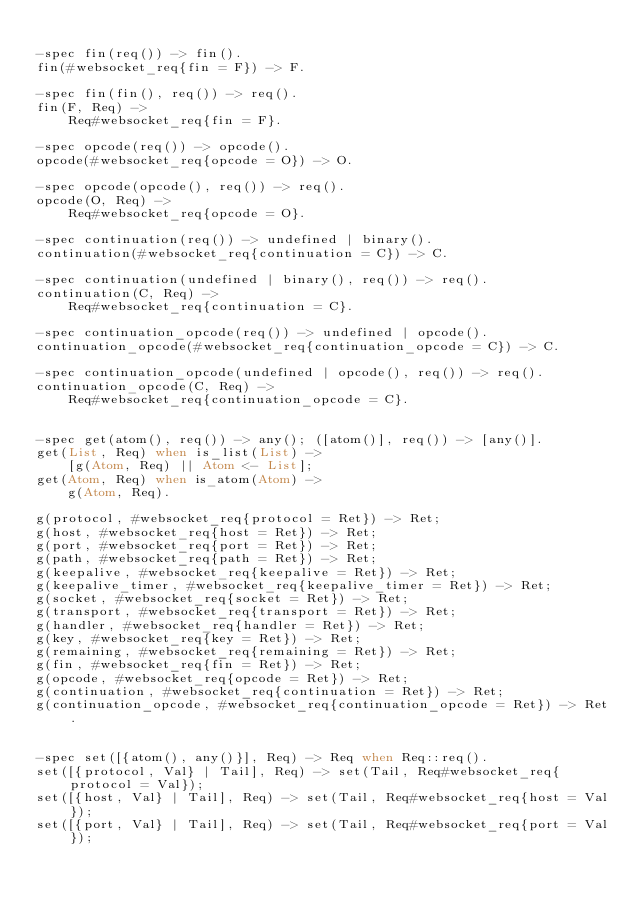Convert code to text. <code><loc_0><loc_0><loc_500><loc_500><_Erlang_>
-spec fin(req()) -> fin().
fin(#websocket_req{fin = F}) -> F.

-spec fin(fin(), req()) -> req().
fin(F, Req) ->
    Req#websocket_req{fin = F}.

-spec opcode(req()) -> opcode().
opcode(#websocket_req{opcode = O}) -> O.

-spec opcode(opcode(), req()) -> req().
opcode(O, Req) ->
    Req#websocket_req{opcode = O}.

-spec continuation(req()) -> undefined | binary().
continuation(#websocket_req{continuation = C}) -> C.

-spec continuation(undefined | binary(), req()) -> req().
continuation(C, Req) ->
    Req#websocket_req{continuation = C}.

-spec continuation_opcode(req()) -> undefined | opcode().
continuation_opcode(#websocket_req{continuation_opcode = C}) -> C.

-spec continuation_opcode(undefined | opcode(), req()) -> req().
continuation_opcode(C, Req) ->
    Req#websocket_req{continuation_opcode = C}.


-spec get(atom(), req()) -> any(); ([atom()], req()) -> [any()].
get(List, Req) when is_list(List) ->
    [g(Atom, Req) || Atom <- List];
get(Atom, Req) when is_atom(Atom) ->
    g(Atom, Req).

g(protocol, #websocket_req{protocol = Ret}) -> Ret;
g(host, #websocket_req{host = Ret}) -> Ret;
g(port, #websocket_req{port = Ret}) -> Ret;
g(path, #websocket_req{path = Ret}) -> Ret;
g(keepalive, #websocket_req{keepalive = Ret}) -> Ret;
g(keepalive_timer, #websocket_req{keepalive_timer = Ret}) -> Ret;
g(socket, #websocket_req{socket = Ret}) -> Ret;
g(transport, #websocket_req{transport = Ret}) -> Ret;
g(handler, #websocket_req{handler = Ret}) -> Ret;
g(key, #websocket_req{key = Ret}) -> Ret;
g(remaining, #websocket_req{remaining = Ret}) -> Ret;
g(fin, #websocket_req{fin = Ret}) -> Ret;
g(opcode, #websocket_req{opcode = Ret}) -> Ret;
g(continuation, #websocket_req{continuation = Ret}) -> Ret;
g(continuation_opcode, #websocket_req{continuation_opcode = Ret}) -> Ret.


-spec set([{atom(), any()}], Req) -> Req when Req::req().
set([{protocol, Val} | Tail], Req) -> set(Tail, Req#websocket_req{protocol = Val});
set([{host, Val} | Tail], Req) -> set(Tail, Req#websocket_req{host = Val});
set([{port, Val} | Tail], Req) -> set(Tail, Req#websocket_req{port = Val});</code> 